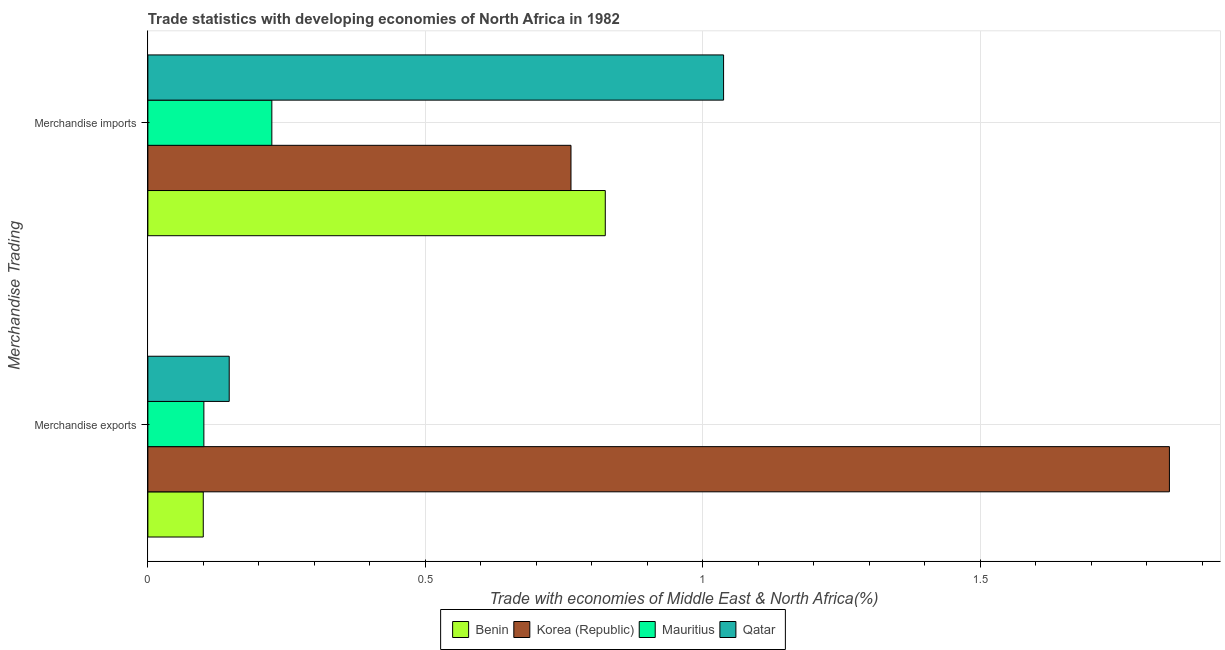How many groups of bars are there?
Provide a succinct answer. 2. How many bars are there on the 1st tick from the top?
Keep it short and to the point. 4. How many bars are there on the 2nd tick from the bottom?
Your answer should be very brief. 4. What is the merchandise imports in Qatar?
Ensure brevity in your answer.  1.04. Across all countries, what is the maximum merchandise imports?
Your answer should be very brief. 1.04. Across all countries, what is the minimum merchandise exports?
Offer a terse response. 0.1. In which country was the merchandise exports maximum?
Your answer should be very brief. Korea (Republic). In which country was the merchandise exports minimum?
Ensure brevity in your answer.  Benin. What is the total merchandise imports in the graph?
Offer a very short reply. 2.85. What is the difference between the merchandise imports in Benin and that in Korea (Republic)?
Your answer should be compact. 0.06. What is the difference between the merchandise imports in Mauritius and the merchandise exports in Qatar?
Make the answer very short. 0.08. What is the average merchandise exports per country?
Give a very brief answer. 0.55. What is the difference between the merchandise imports and merchandise exports in Korea (Republic)?
Offer a terse response. -1.08. In how many countries, is the merchandise exports greater than 0.30000000000000004 %?
Offer a very short reply. 1. What is the ratio of the merchandise imports in Benin to that in Mauritius?
Offer a terse response. 3.69. In how many countries, is the merchandise exports greater than the average merchandise exports taken over all countries?
Ensure brevity in your answer.  1. What does the 1st bar from the top in Merchandise exports represents?
Your answer should be very brief. Qatar. What does the 1st bar from the bottom in Merchandise exports represents?
Keep it short and to the point. Benin. How many bars are there?
Offer a terse response. 8. Are the values on the major ticks of X-axis written in scientific E-notation?
Your answer should be compact. No. Does the graph contain any zero values?
Make the answer very short. No. Does the graph contain grids?
Keep it short and to the point. Yes. What is the title of the graph?
Your response must be concise. Trade statistics with developing economies of North Africa in 1982. Does "Singapore" appear as one of the legend labels in the graph?
Provide a short and direct response. No. What is the label or title of the X-axis?
Your answer should be compact. Trade with economies of Middle East & North Africa(%). What is the label or title of the Y-axis?
Your answer should be compact. Merchandise Trading. What is the Trade with economies of Middle East & North Africa(%) in Benin in Merchandise exports?
Offer a terse response. 0.1. What is the Trade with economies of Middle East & North Africa(%) in Korea (Republic) in Merchandise exports?
Your response must be concise. 1.84. What is the Trade with economies of Middle East & North Africa(%) of Mauritius in Merchandise exports?
Provide a succinct answer. 0.1. What is the Trade with economies of Middle East & North Africa(%) of Qatar in Merchandise exports?
Offer a terse response. 0.15. What is the Trade with economies of Middle East & North Africa(%) in Benin in Merchandise imports?
Your response must be concise. 0.82. What is the Trade with economies of Middle East & North Africa(%) in Korea (Republic) in Merchandise imports?
Make the answer very short. 0.76. What is the Trade with economies of Middle East & North Africa(%) in Mauritius in Merchandise imports?
Provide a short and direct response. 0.22. What is the Trade with economies of Middle East & North Africa(%) of Qatar in Merchandise imports?
Provide a short and direct response. 1.04. Across all Merchandise Trading, what is the maximum Trade with economies of Middle East & North Africa(%) of Benin?
Keep it short and to the point. 0.82. Across all Merchandise Trading, what is the maximum Trade with economies of Middle East & North Africa(%) of Korea (Republic)?
Make the answer very short. 1.84. Across all Merchandise Trading, what is the maximum Trade with economies of Middle East & North Africa(%) of Mauritius?
Make the answer very short. 0.22. Across all Merchandise Trading, what is the maximum Trade with economies of Middle East & North Africa(%) of Qatar?
Your answer should be very brief. 1.04. Across all Merchandise Trading, what is the minimum Trade with economies of Middle East & North Africa(%) in Benin?
Provide a succinct answer. 0.1. Across all Merchandise Trading, what is the minimum Trade with economies of Middle East & North Africa(%) of Korea (Republic)?
Offer a very short reply. 0.76. Across all Merchandise Trading, what is the minimum Trade with economies of Middle East & North Africa(%) of Mauritius?
Offer a very short reply. 0.1. Across all Merchandise Trading, what is the minimum Trade with economies of Middle East & North Africa(%) of Qatar?
Your answer should be compact. 0.15. What is the total Trade with economies of Middle East & North Africa(%) of Benin in the graph?
Make the answer very short. 0.92. What is the total Trade with economies of Middle East & North Africa(%) in Korea (Republic) in the graph?
Offer a very short reply. 2.6. What is the total Trade with economies of Middle East & North Africa(%) of Mauritius in the graph?
Your answer should be very brief. 0.32. What is the total Trade with economies of Middle East & North Africa(%) of Qatar in the graph?
Provide a short and direct response. 1.18. What is the difference between the Trade with economies of Middle East & North Africa(%) of Benin in Merchandise exports and that in Merchandise imports?
Offer a terse response. -0.72. What is the difference between the Trade with economies of Middle East & North Africa(%) in Korea (Republic) in Merchandise exports and that in Merchandise imports?
Provide a succinct answer. 1.08. What is the difference between the Trade with economies of Middle East & North Africa(%) in Mauritius in Merchandise exports and that in Merchandise imports?
Give a very brief answer. -0.12. What is the difference between the Trade with economies of Middle East & North Africa(%) of Qatar in Merchandise exports and that in Merchandise imports?
Provide a short and direct response. -0.89. What is the difference between the Trade with economies of Middle East & North Africa(%) of Benin in Merchandise exports and the Trade with economies of Middle East & North Africa(%) of Korea (Republic) in Merchandise imports?
Keep it short and to the point. -0.66. What is the difference between the Trade with economies of Middle East & North Africa(%) in Benin in Merchandise exports and the Trade with economies of Middle East & North Africa(%) in Mauritius in Merchandise imports?
Offer a very short reply. -0.12. What is the difference between the Trade with economies of Middle East & North Africa(%) of Benin in Merchandise exports and the Trade with economies of Middle East & North Africa(%) of Qatar in Merchandise imports?
Provide a succinct answer. -0.94. What is the difference between the Trade with economies of Middle East & North Africa(%) in Korea (Republic) in Merchandise exports and the Trade with economies of Middle East & North Africa(%) in Mauritius in Merchandise imports?
Your answer should be very brief. 1.62. What is the difference between the Trade with economies of Middle East & North Africa(%) in Korea (Republic) in Merchandise exports and the Trade with economies of Middle East & North Africa(%) in Qatar in Merchandise imports?
Make the answer very short. 0.8. What is the difference between the Trade with economies of Middle East & North Africa(%) in Mauritius in Merchandise exports and the Trade with economies of Middle East & North Africa(%) in Qatar in Merchandise imports?
Make the answer very short. -0.94. What is the average Trade with economies of Middle East & North Africa(%) of Benin per Merchandise Trading?
Ensure brevity in your answer.  0.46. What is the average Trade with economies of Middle East & North Africa(%) of Korea (Republic) per Merchandise Trading?
Make the answer very short. 1.3. What is the average Trade with economies of Middle East & North Africa(%) in Mauritius per Merchandise Trading?
Keep it short and to the point. 0.16. What is the average Trade with economies of Middle East & North Africa(%) of Qatar per Merchandise Trading?
Your answer should be compact. 0.59. What is the difference between the Trade with economies of Middle East & North Africa(%) of Benin and Trade with economies of Middle East & North Africa(%) of Korea (Republic) in Merchandise exports?
Make the answer very short. -1.74. What is the difference between the Trade with economies of Middle East & North Africa(%) of Benin and Trade with economies of Middle East & North Africa(%) of Mauritius in Merchandise exports?
Your answer should be very brief. -0. What is the difference between the Trade with economies of Middle East & North Africa(%) in Benin and Trade with economies of Middle East & North Africa(%) in Qatar in Merchandise exports?
Provide a succinct answer. -0.05. What is the difference between the Trade with economies of Middle East & North Africa(%) of Korea (Republic) and Trade with economies of Middle East & North Africa(%) of Mauritius in Merchandise exports?
Your answer should be compact. 1.74. What is the difference between the Trade with economies of Middle East & North Africa(%) of Korea (Republic) and Trade with economies of Middle East & North Africa(%) of Qatar in Merchandise exports?
Provide a succinct answer. 1.69. What is the difference between the Trade with economies of Middle East & North Africa(%) of Mauritius and Trade with economies of Middle East & North Africa(%) of Qatar in Merchandise exports?
Offer a terse response. -0.05. What is the difference between the Trade with economies of Middle East & North Africa(%) in Benin and Trade with economies of Middle East & North Africa(%) in Korea (Republic) in Merchandise imports?
Keep it short and to the point. 0.06. What is the difference between the Trade with economies of Middle East & North Africa(%) of Benin and Trade with economies of Middle East & North Africa(%) of Mauritius in Merchandise imports?
Give a very brief answer. 0.6. What is the difference between the Trade with economies of Middle East & North Africa(%) in Benin and Trade with economies of Middle East & North Africa(%) in Qatar in Merchandise imports?
Make the answer very short. -0.21. What is the difference between the Trade with economies of Middle East & North Africa(%) in Korea (Republic) and Trade with economies of Middle East & North Africa(%) in Mauritius in Merchandise imports?
Your response must be concise. 0.54. What is the difference between the Trade with economies of Middle East & North Africa(%) of Korea (Republic) and Trade with economies of Middle East & North Africa(%) of Qatar in Merchandise imports?
Ensure brevity in your answer.  -0.28. What is the difference between the Trade with economies of Middle East & North Africa(%) in Mauritius and Trade with economies of Middle East & North Africa(%) in Qatar in Merchandise imports?
Your answer should be very brief. -0.81. What is the ratio of the Trade with economies of Middle East & North Africa(%) of Benin in Merchandise exports to that in Merchandise imports?
Provide a succinct answer. 0.12. What is the ratio of the Trade with economies of Middle East & North Africa(%) of Korea (Republic) in Merchandise exports to that in Merchandise imports?
Ensure brevity in your answer.  2.41. What is the ratio of the Trade with economies of Middle East & North Africa(%) in Mauritius in Merchandise exports to that in Merchandise imports?
Your response must be concise. 0.45. What is the ratio of the Trade with economies of Middle East & North Africa(%) in Qatar in Merchandise exports to that in Merchandise imports?
Offer a terse response. 0.14. What is the difference between the highest and the second highest Trade with economies of Middle East & North Africa(%) in Benin?
Give a very brief answer. 0.72. What is the difference between the highest and the second highest Trade with economies of Middle East & North Africa(%) in Korea (Republic)?
Offer a terse response. 1.08. What is the difference between the highest and the second highest Trade with economies of Middle East & North Africa(%) in Mauritius?
Provide a succinct answer. 0.12. What is the difference between the highest and the second highest Trade with economies of Middle East & North Africa(%) of Qatar?
Give a very brief answer. 0.89. What is the difference between the highest and the lowest Trade with economies of Middle East & North Africa(%) in Benin?
Offer a very short reply. 0.72. What is the difference between the highest and the lowest Trade with economies of Middle East & North Africa(%) in Korea (Republic)?
Your answer should be compact. 1.08. What is the difference between the highest and the lowest Trade with economies of Middle East & North Africa(%) in Mauritius?
Provide a short and direct response. 0.12. What is the difference between the highest and the lowest Trade with economies of Middle East & North Africa(%) in Qatar?
Your response must be concise. 0.89. 